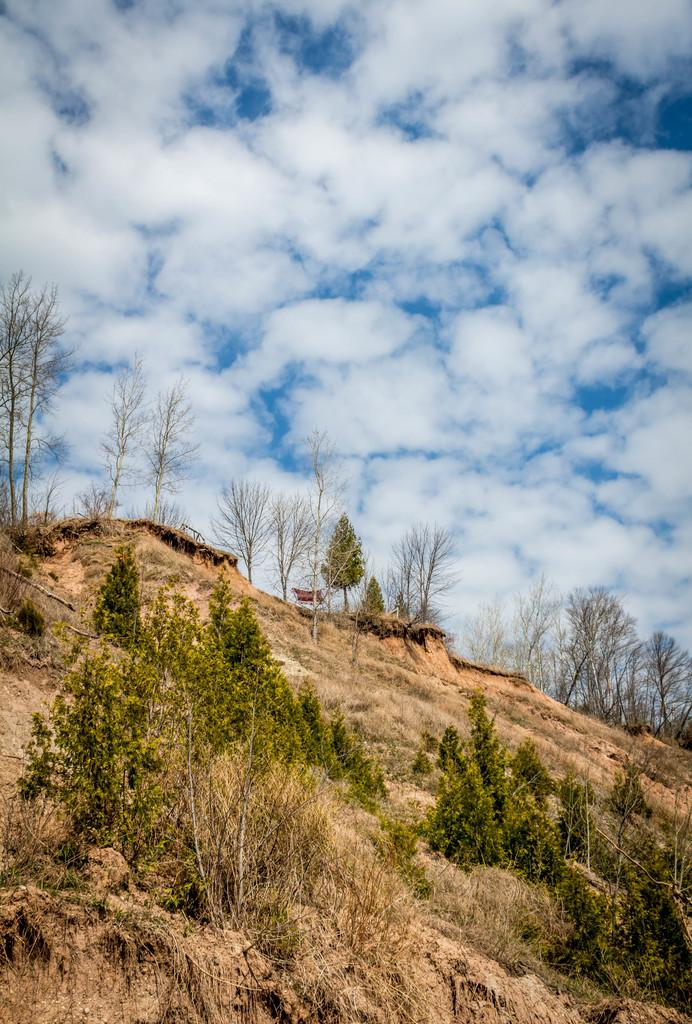What type of vegetation can be seen in the image? There are trees in the image. What geographical feature is visible in the image? There is a mountain in the image. What part of the natural environment is visible in the image? The sky is visible in the background of the image. What can be seen in the sky? Clouds are present in the sky. What is the favorite hobby of the fireman in the image? There is no fireman present in the image. How many trees are there in the image? The number of trees cannot be determined from the image alone, as it only shows that there are trees present. 